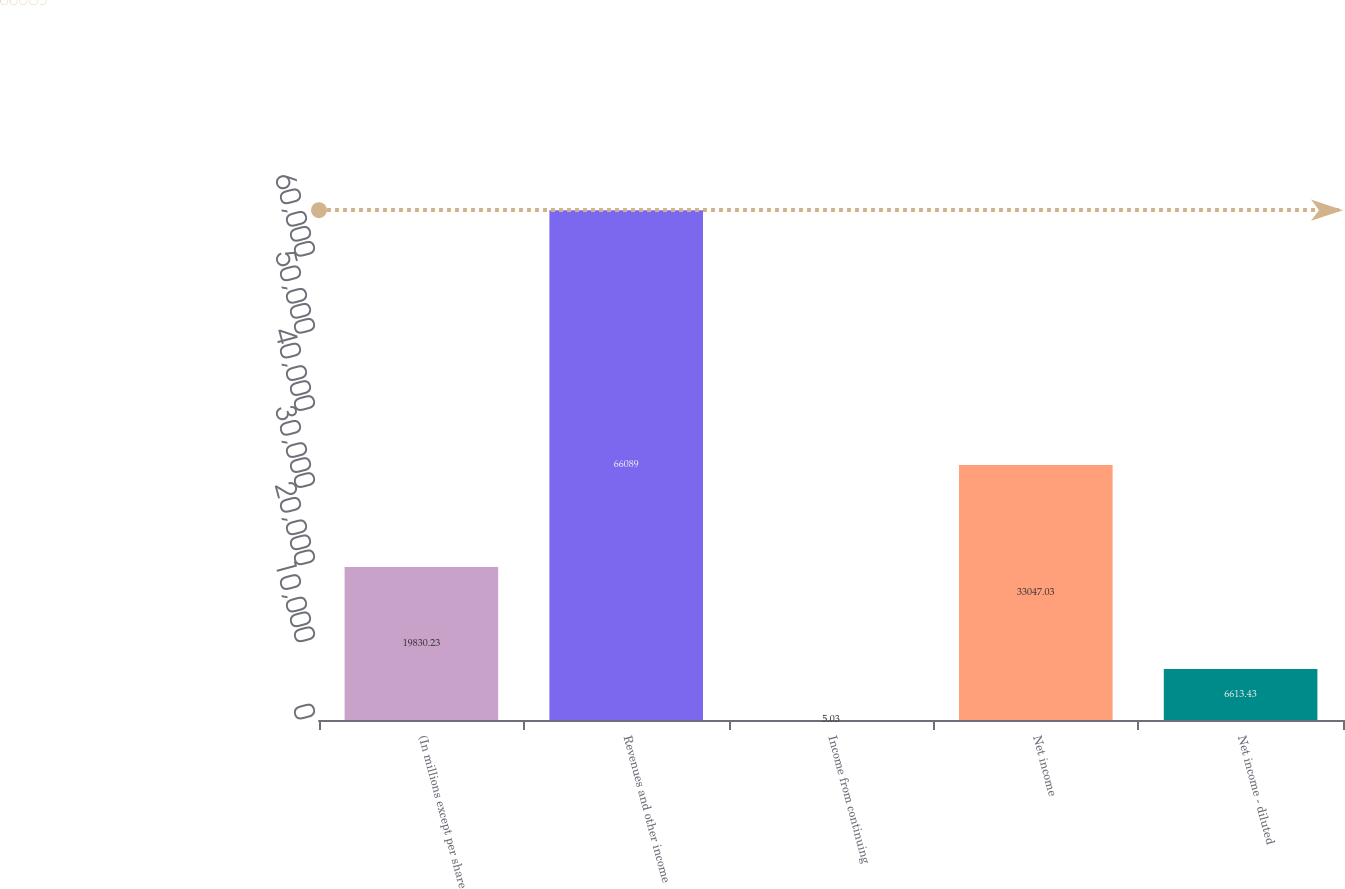<chart> <loc_0><loc_0><loc_500><loc_500><bar_chart><fcel>(In millions except per share<fcel>Revenues and other income<fcel>Income from continuing<fcel>Net income<fcel>Net income - diluted<nl><fcel>19830.2<fcel>66089<fcel>5.03<fcel>33047<fcel>6613.43<nl></chart> 